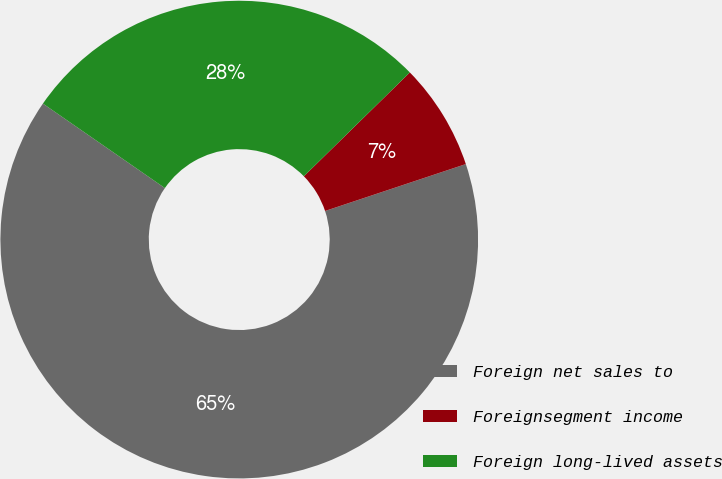Convert chart. <chart><loc_0><loc_0><loc_500><loc_500><pie_chart><fcel>Foreign net sales to<fcel>Foreignsegment income<fcel>Foreign long-lived assets<nl><fcel>64.77%<fcel>7.22%<fcel>28.02%<nl></chart> 